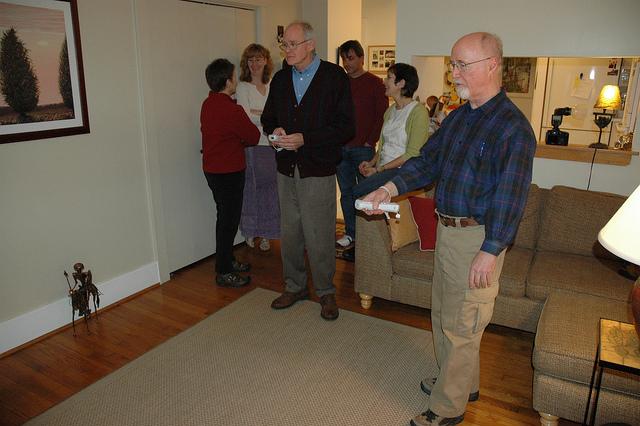Are the girls standing?
Answer briefly. Yes. Does it appear that the men are enjoying the game?
Answer briefly. Yes. What is the man holding?
Be succinct. Controller. Is the dog's bed in this room?
Give a very brief answer. No. What kind of floor is the man standing on?
Give a very brief answer. Wood. How many people are standing?
Quick response, please. 6. Is the door open?
Be succinct. No. Is this man wearing shoes?
Write a very short answer. Yes. How many people are female?
Short answer required. 3. Are both people wearing glasses?
Give a very brief answer. Yes. How many people are in the photo?
Short answer required. 6. What are the man doing?
Quick response, please. Playing wii. What is the man's job?
Concise answer only. Unknown. What is the man in the plaid shirt holding in his hand?
Give a very brief answer. Wii remote. Who is wearing the red shirt?
Write a very short answer. Woman. 